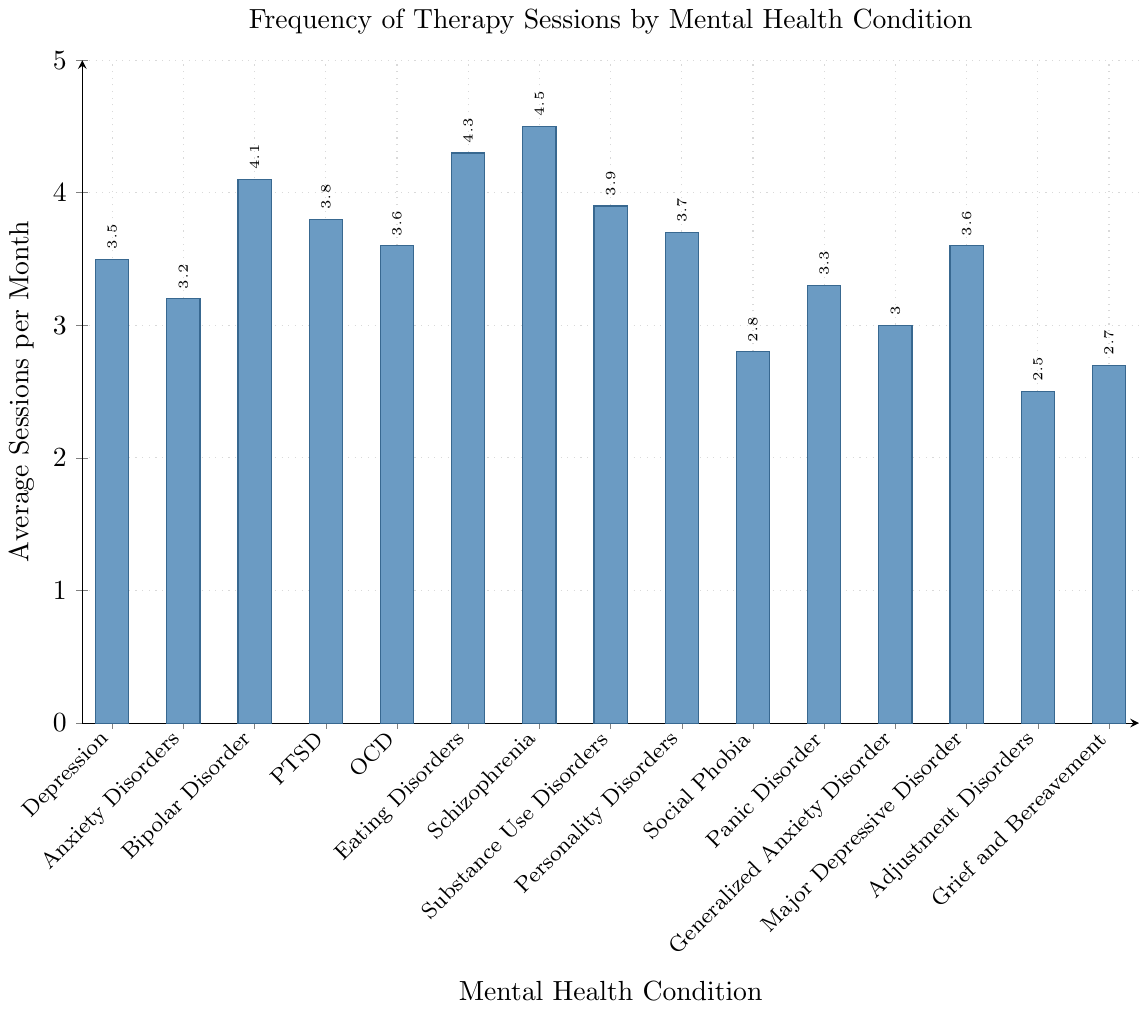Which mental health condition has the highest average number of therapy sessions per month? By looking at the height of the bars representing each mental health condition, the bar for Schizophrenia is the tallest.
Answer: Schizophrenia Which conditions have an average of more than 4 therapy sessions per month? Identify the bars that exceed the y-value of 4. Bars for Bipolar Disorder, Eating Disorders, and Schizophrenia are taller than the 4 mark.
Answer: Bipolar Disorder, Eating Disorders, Schizophrenia What's the difference in the average number of sessions per month between Adjustment Disorders and Eating Disorders? Subtract the average sessions for Adjustment Disorders (2.5) from that of Eating Disorders (4.3). Calculation: 4.3 - 2.5 = 1.8.
Answer: 1.8 Which condition has the least average number of therapy sessions per month? Locate the shortest bar on the chart, which corresponds to Adjustment Disorders.
Answer: Adjustment Disorders How many more sessions does Schizophrenia have compared to Generalized Anxiety Disorder on average per month? Subtract the average sessions for Generalized Anxiety Disorder (3.0) from that of Schizophrenia (4.5). Calculation: 4.5 - 3.0 = 1.5.
Answer: 1.5 Which conditions have an average number of sessions per month between 3 and 4? Identify the bars with a height between the y-values of 3 and 4. These include Depression, Anxiety Disorders, PTSD, OCD, Substance Use Disorders, Personality Disorders, Panic Disorder, Major Depressive Disorder, and Generalized Anxiety Disorder.
Answer: Depression, Anxiety Disorders, PTSD, OCD, Substance Use Disorders, Personality Disorders, Panic Disorder, Major Depressive Disorder, Generalized Anxiety Disorder What is the average number of sessions per month for Depression and Bipolar Disorder combined? Add the average sessions for Depression (3.5) and Bipolar Disorder (4.1) and then divide by 2. Calculation: (3.5 + 4.1) / 2 = 3.8.
Answer: 3.8 How does the average number of sessions for PTSD compare to Major Depressive Disorder? Compare the y-values of the bars for PTSD (3.8) and Major Depressive Disorder (3.6). PTSD has slightly higher average sessions.
Answer: PTSD has more (0.2 more) What is the combined total of average sessions per month for Social Phobia and Grief and Bereavement? Add the average sessions for Social Phobia (2.8) and Grief and Bereavement (2.7). Calculation: 2.8 + 2.7 = 5.5.
Answer: 5.5 Which condition's average sessions per month is closest to the average of all conditions listed? Find the average of all given conditions and then determine the closest individual average. Calculation: (3.5 + 3.2 + 4.1 + 3.8 + 3.6 + 4.3 + 4.5 + 3.9 + 3.7 + 2.8 + 3.3 + 3.0 + 3.6 + 2.5 + 2.7) / 15 = 3.5. The closest is Depression and Major Depressive Disorder both at 3.5 and 3.6 respectively.
Answer: Depression and Major Depressive Disorder 